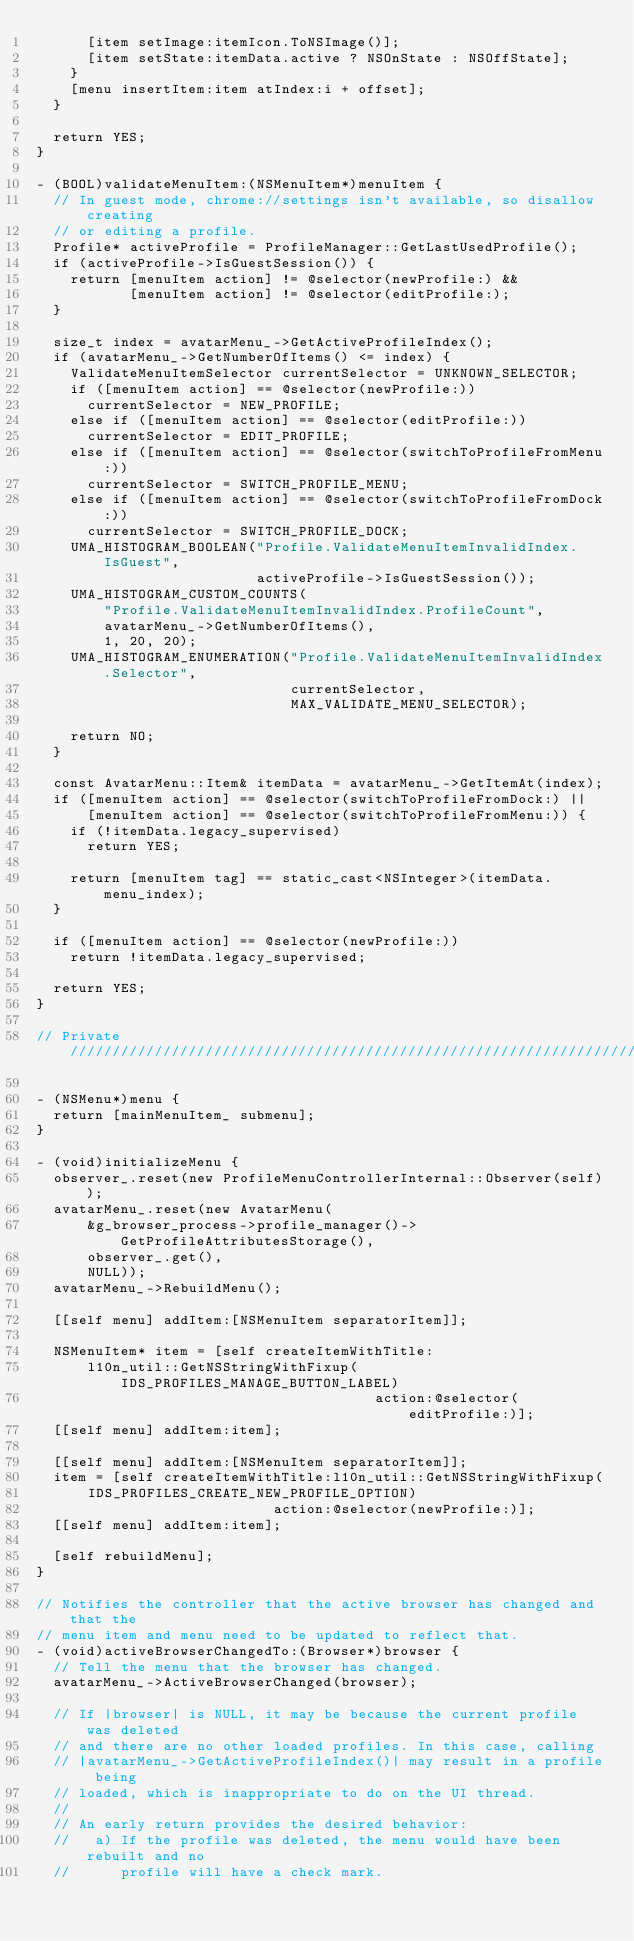Convert code to text. <code><loc_0><loc_0><loc_500><loc_500><_ObjectiveC_>      [item setImage:itemIcon.ToNSImage()];
      [item setState:itemData.active ? NSOnState : NSOffState];
    }
    [menu insertItem:item atIndex:i + offset];
  }

  return YES;
}

- (BOOL)validateMenuItem:(NSMenuItem*)menuItem {
  // In guest mode, chrome://settings isn't available, so disallow creating
  // or editing a profile.
  Profile* activeProfile = ProfileManager::GetLastUsedProfile();
  if (activeProfile->IsGuestSession()) {
    return [menuItem action] != @selector(newProfile:) &&
           [menuItem action] != @selector(editProfile:);
  }

  size_t index = avatarMenu_->GetActiveProfileIndex();
  if (avatarMenu_->GetNumberOfItems() <= index) {
    ValidateMenuItemSelector currentSelector = UNKNOWN_SELECTOR;
    if ([menuItem action] == @selector(newProfile:))
      currentSelector = NEW_PROFILE;
    else if ([menuItem action] == @selector(editProfile:))
      currentSelector = EDIT_PROFILE;
    else if ([menuItem action] == @selector(switchToProfileFromMenu:))
      currentSelector = SWITCH_PROFILE_MENU;
    else if ([menuItem action] == @selector(switchToProfileFromDock:))
      currentSelector = SWITCH_PROFILE_DOCK;
    UMA_HISTOGRAM_BOOLEAN("Profile.ValidateMenuItemInvalidIndex.IsGuest",
                          activeProfile->IsGuestSession());
    UMA_HISTOGRAM_CUSTOM_COUNTS(
        "Profile.ValidateMenuItemInvalidIndex.ProfileCount",
        avatarMenu_->GetNumberOfItems(),
        1, 20, 20);
    UMA_HISTOGRAM_ENUMERATION("Profile.ValidateMenuItemInvalidIndex.Selector",
                              currentSelector,
                              MAX_VALIDATE_MENU_SELECTOR);

    return NO;
  }

  const AvatarMenu::Item& itemData = avatarMenu_->GetItemAt(index);
  if ([menuItem action] == @selector(switchToProfileFromDock:) ||
      [menuItem action] == @selector(switchToProfileFromMenu:)) {
    if (!itemData.legacy_supervised)
      return YES;

    return [menuItem tag] == static_cast<NSInteger>(itemData.menu_index);
  }

  if ([menuItem action] == @selector(newProfile:))
    return !itemData.legacy_supervised;

  return YES;
}

// Private /////////////////////////////////////////////////////////////////////

- (NSMenu*)menu {
  return [mainMenuItem_ submenu];
}

- (void)initializeMenu {
  observer_.reset(new ProfileMenuControllerInternal::Observer(self));
  avatarMenu_.reset(new AvatarMenu(
      &g_browser_process->profile_manager()->GetProfileAttributesStorage(),
      observer_.get(),
      NULL));
  avatarMenu_->RebuildMenu();

  [[self menu] addItem:[NSMenuItem separatorItem]];

  NSMenuItem* item = [self createItemWithTitle:
      l10n_util::GetNSStringWithFixup(IDS_PROFILES_MANAGE_BUTTON_LABEL)
                                        action:@selector(editProfile:)];
  [[self menu] addItem:item];

  [[self menu] addItem:[NSMenuItem separatorItem]];
  item = [self createItemWithTitle:l10n_util::GetNSStringWithFixup(
      IDS_PROFILES_CREATE_NEW_PROFILE_OPTION)
                            action:@selector(newProfile:)];
  [[self menu] addItem:item];

  [self rebuildMenu];
}

// Notifies the controller that the active browser has changed and that the
// menu item and menu need to be updated to reflect that.
- (void)activeBrowserChangedTo:(Browser*)browser {
  // Tell the menu that the browser has changed.
  avatarMenu_->ActiveBrowserChanged(browser);

  // If |browser| is NULL, it may be because the current profile was deleted
  // and there are no other loaded profiles. In this case, calling
  // |avatarMenu_->GetActiveProfileIndex()| may result in a profile being
  // loaded, which is inappropriate to do on the UI thread.
  //
  // An early return provides the desired behavior:
  //   a) If the profile was deleted, the menu would have been rebuilt and no
  //      profile will have a check mark.</code> 